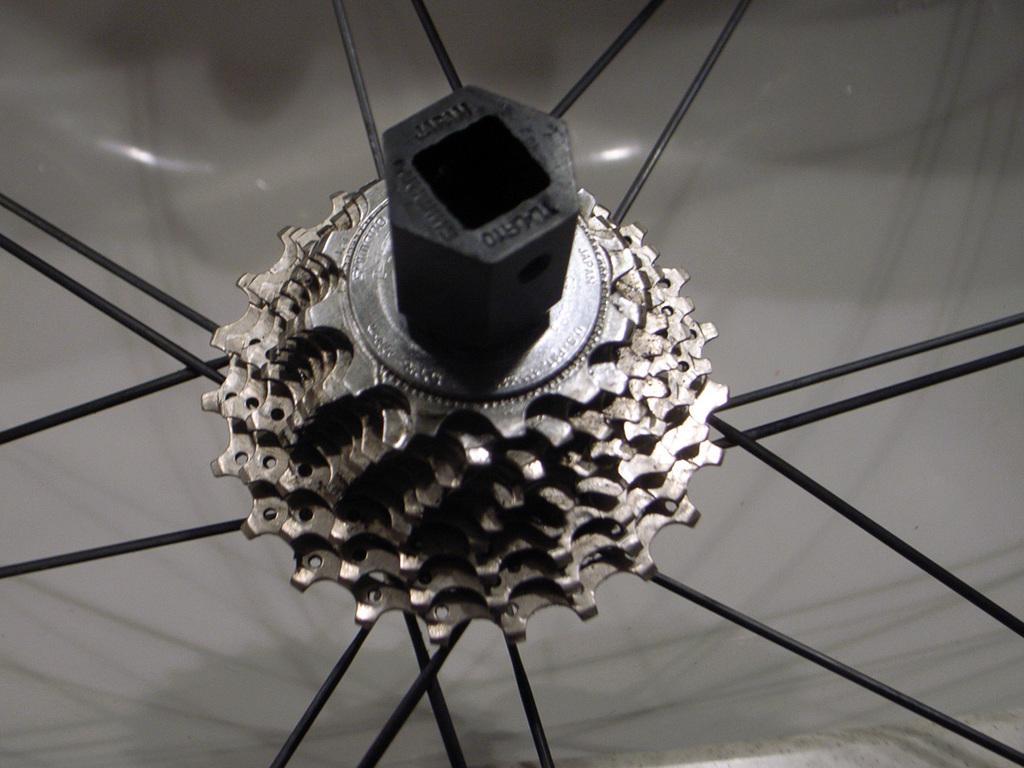In one or two sentences, can you explain what this image depicts? In this image we can see gears and some spokes. 